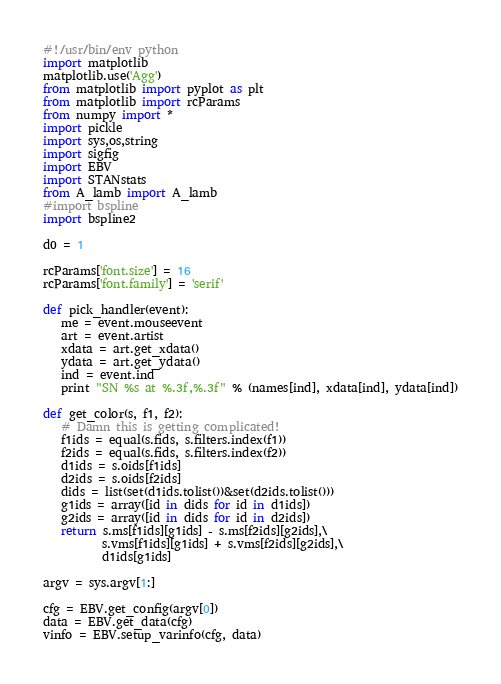Convert code to text. <code><loc_0><loc_0><loc_500><loc_500><_Python_>#!/usr/bin/env python
import matplotlib
matplotlib.use('Agg')
from matplotlib import pyplot as plt
from matplotlib import rcParams
from numpy import *
import pickle
import sys,os,string
import sigfig
import EBV
import STANstats
from A_lamb import A_lamb
#import bspline
import bspline2

d0 = 1

rcParams['font.size'] = 16
rcParams['font.family'] = 'serif'

def pick_handler(event):
   me = event.mouseevent
   art = event.artist
   xdata = art.get_xdata()
   ydata = art.get_ydata()
   ind = event.ind
   print "SN %s at %.3f,%.3f" % (names[ind], xdata[ind], ydata[ind])

def get_color(s, f1, f2):
   # Damn this is getting complicated!
   f1ids = equal(s.fids, s.filters.index(f1))
   f2ids = equal(s.fids, s.filters.index(f2))
   d1ids = s.oids[f1ids]
   d2ids = s.oids[f2ids]
   dids = list(set(d1ids.tolist())&set(d2ids.tolist()))
   g1ids = array([id in dids for id in d1ids])
   g2ids = array([id in dids for id in d2ids])
   return s.ms[f1ids][g1ids] - s.ms[f2ids][g2ids],\
          s.vms[f1ids][g1ids] + s.vms[f2ids][g2ids],\
          d1ids[g1ids]

argv = sys.argv[1:]

cfg = EBV.get_config(argv[0])
data = EBV.get_data(cfg)
vinfo = EBV.setup_varinfo(cfg, data)
</code> 